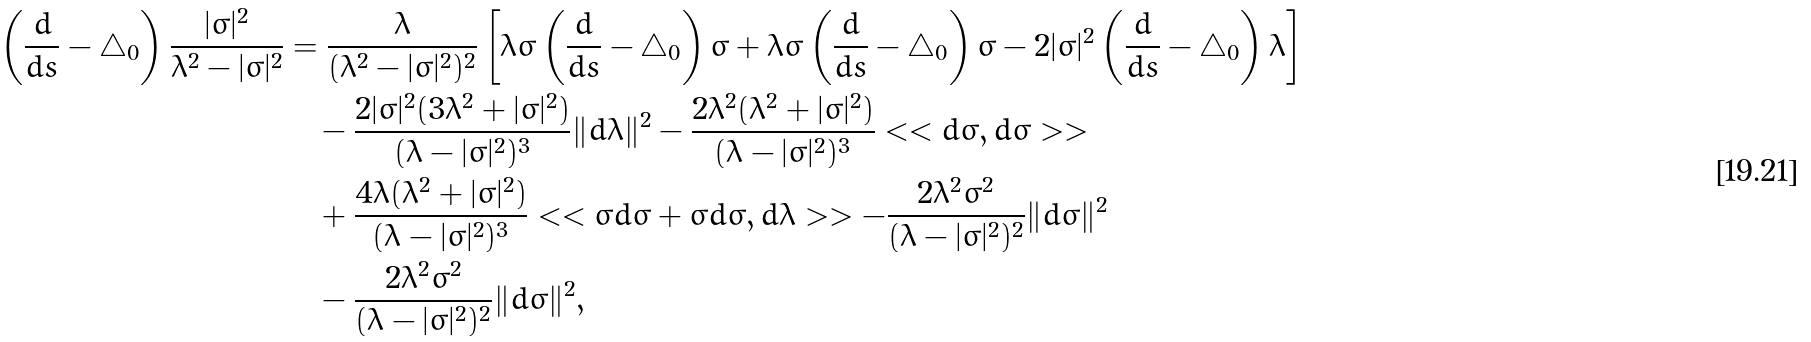<formula> <loc_0><loc_0><loc_500><loc_500>\left ( \frac { d } { d s } - \triangle _ { 0 } \right ) \frac { | \sigma | ^ { 2 } } { \lambda ^ { 2 } - | \sigma | ^ { 2 } } & = \frac { \lambda } { ( \lambda ^ { 2 } - | \sigma | ^ { 2 } ) ^ { 2 } } \left [ \lambda \sigma \left ( \frac { d } { d s } - \triangle _ { 0 } \right ) \bar { \sigma } + \lambda \bar { \sigma } \left ( \frac { d } { d s } - \triangle _ { 0 } \right ) \sigma - 2 | \sigma | ^ { 2 } \left ( \frac { d } { d s } - \triangle _ { 0 } \right ) \lambda \right ] \\ & \quad - \frac { 2 | \sigma | ^ { 2 } ( 3 \lambda ^ { 2 } + | \sigma | ^ { 2 } ) } { ( \lambda - | \sigma | ^ { 2 } ) ^ { 3 } } \| d \lambda \| ^ { 2 } - \frac { 2 \lambda ^ { 2 } ( \lambda ^ { 2 } + | \sigma | ^ { 2 } ) } { ( \lambda - | \sigma | ^ { 2 } ) ^ { 3 } } < < d \sigma , d \bar { \sigma } > > \\ & \quad + \frac { 4 \lambda ( \lambda ^ { 2 } + | \sigma | ^ { 2 } ) } { ( \lambda - | \sigma | ^ { 2 } ) ^ { 3 } } < < \sigma d \bar { \sigma } + \bar { \sigma } d \sigma , d \lambda > > - \frac { 2 \lambda ^ { 2 } \sigma ^ { 2 } } { ( \lambda - | \sigma | ^ { 2 } ) ^ { 2 } } \| d \bar { \sigma } \| ^ { 2 } \\ & \quad - \frac { 2 \lambda ^ { 2 } \bar { \sigma } ^ { 2 } } { ( \lambda - | \sigma | ^ { 2 } ) ^ { 2 } } \| d \sigma \| ^ { 2 } ,</formula> 